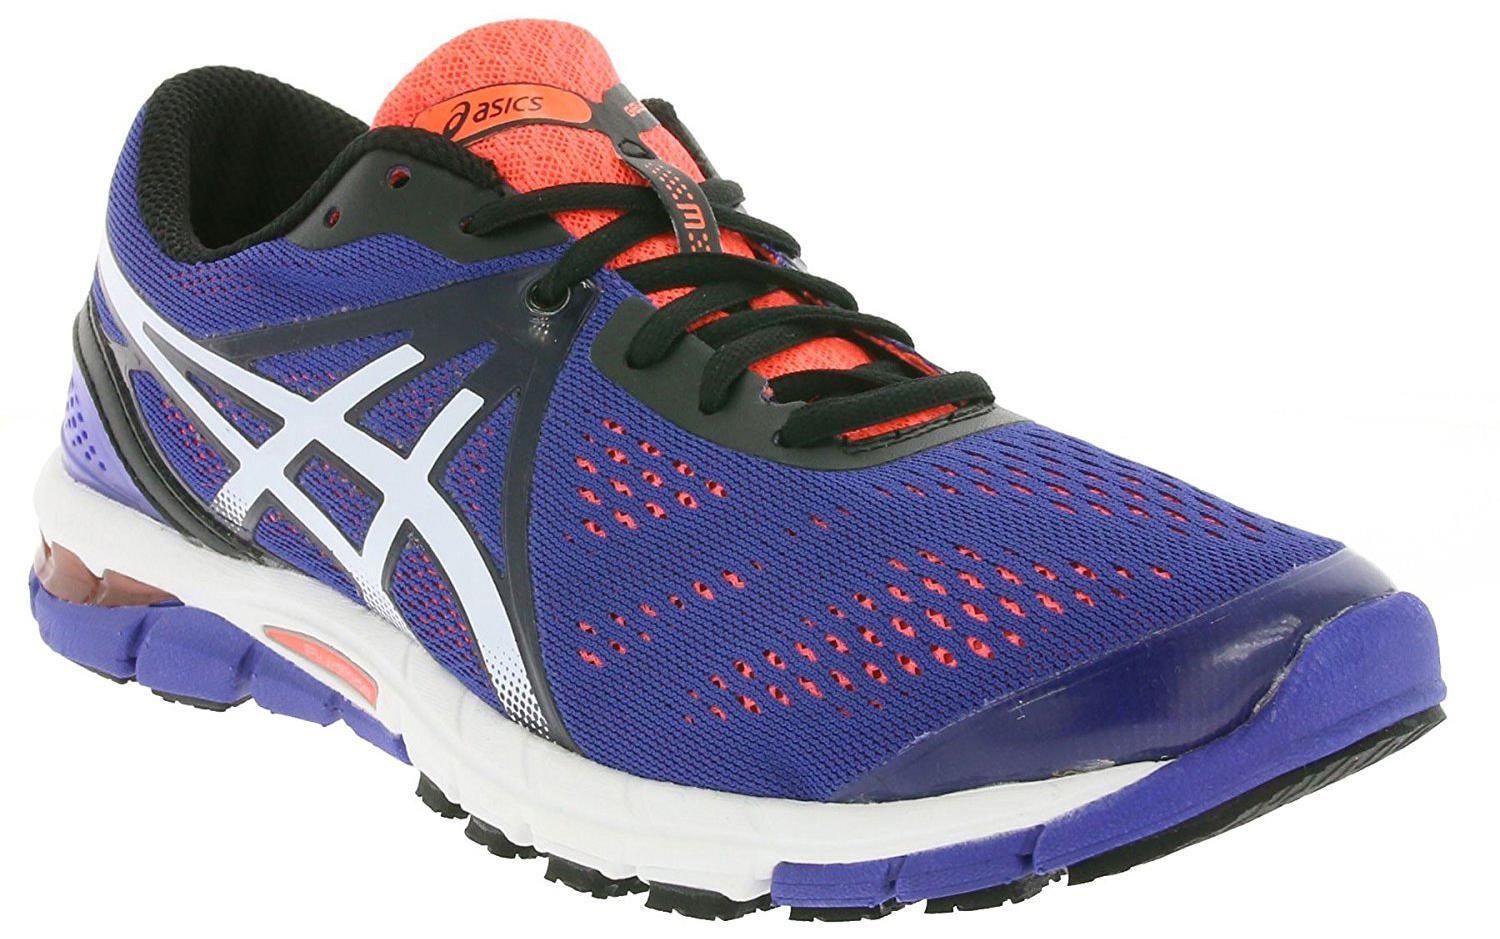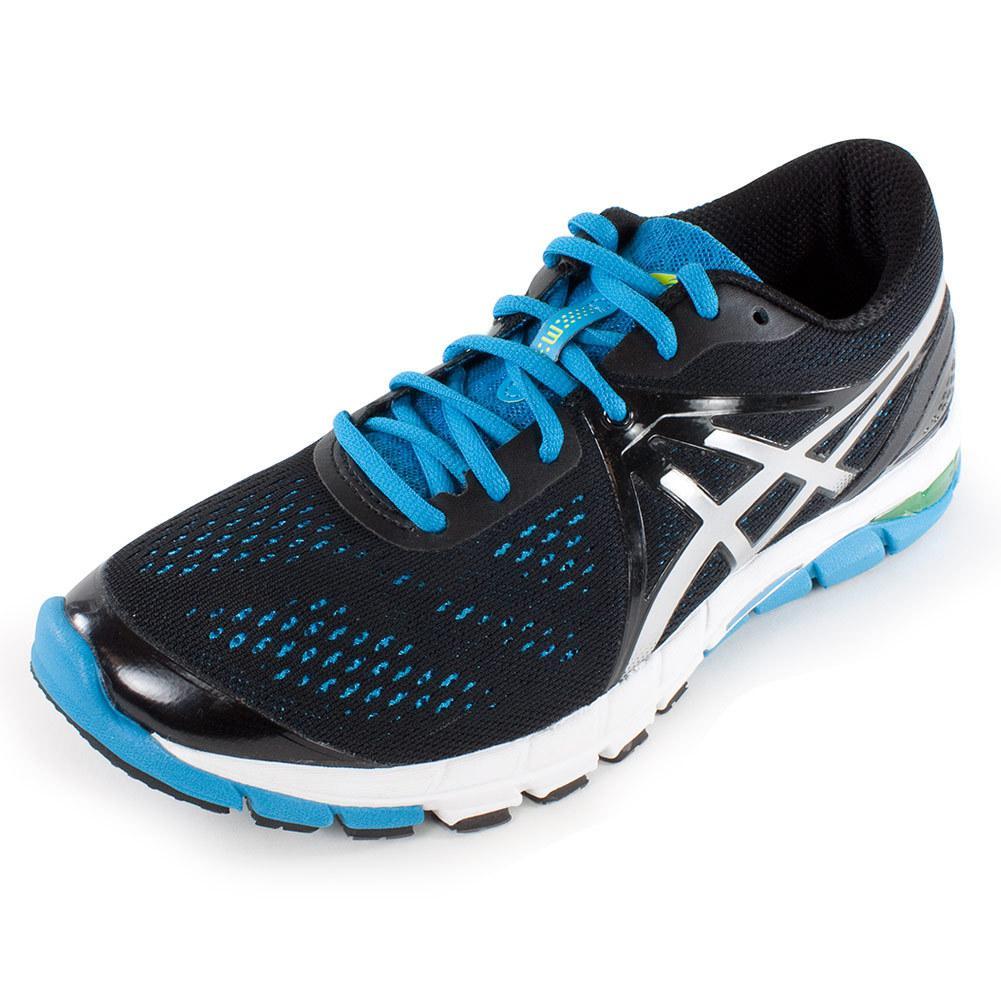The first image is the image on the left, the second image is the image on the right. Analyze the images presented: Is the assertion "At least one shoe is purple with white and orange trim." valid? Answer yes or no. Yes. 